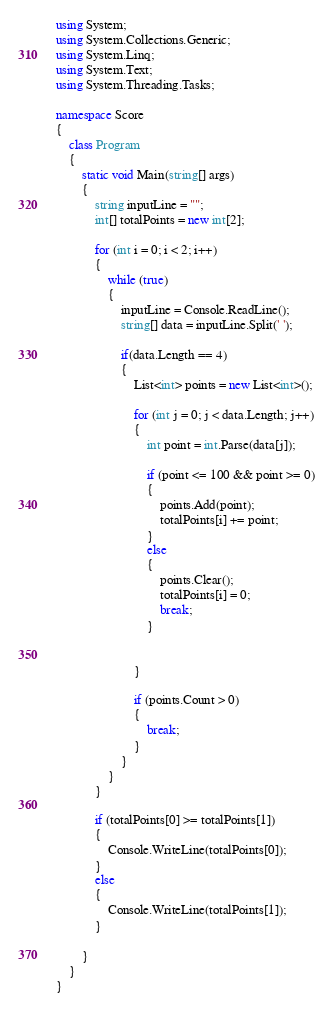<code> <loc_0><loc_0><loc_500><loc_500><_C#_>using System;
using System.Collections.Generic;
using System.Linq;
using System.Text;
using System.Threading.Tasks;

namespace Score
{
    class Program
    {
        static void Main(string[] args)
        {
            string inputLine = "";
            int[] totalPoints = new int[2];

            for (int i = 0; i < 2; i++)
            {
                while (true) 
                {
                    inputLine = Console.ReadLine();
                    string[] data = inputLine.Split(' ');

                    if(data.Length == 4)
                    {
                        List<int> points = new List<int>();

                        for (int j = 0; j < data.Length; j++)
                        {   
                            int point = int.Parse(data[j]);

                            if (point <= 100 && point >= 0)
                            {
                                points.Add(point);
                                totalPoints[i] += point;
                            }
                            else
                            {
                                points.Clear();
                                totalPoints[i] = 0;
                                break;
                            }


                        }

                        if (points.Count > 0)
                        {
                            break;
                        }
                    }
                }
            }

            if (totalPoints[0] >= totalPoints[1])
            {
                Console.WriteLine(totalPoints[0]);
            }
            else
            {
                Console.WriteLine(totalPoints[1]);
            }

        }
    }
}

</code> 